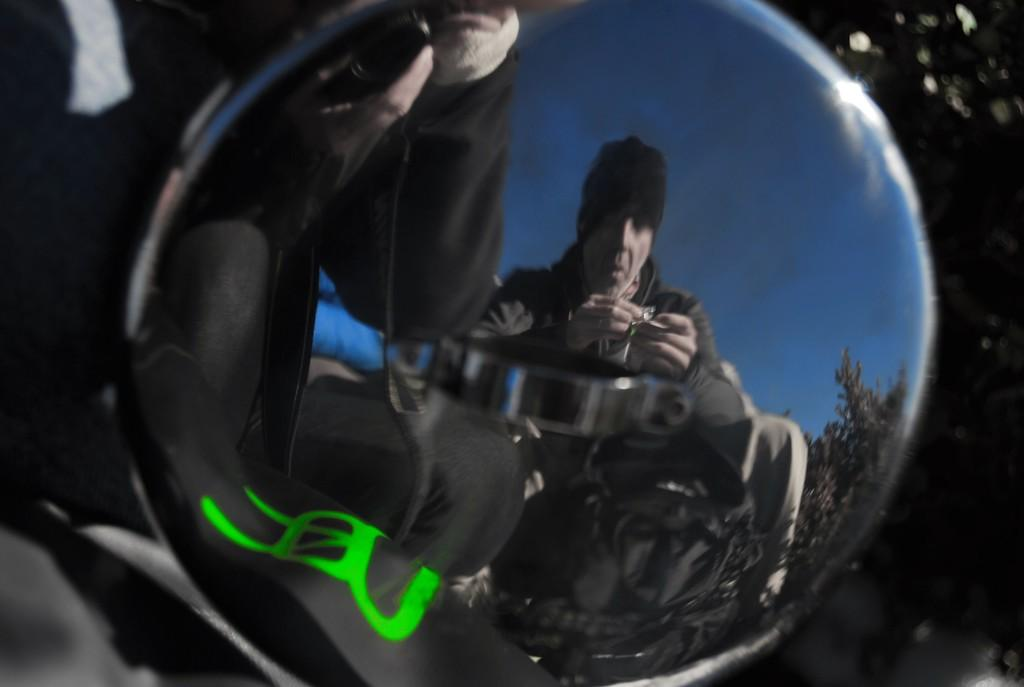How many people are in the image? There are two persons in the image. What can be seen in the background of the image? There is a tree visible in the image, and the sky is also visible. What is the side of the tree that is expanding in the image? There is no indication in the image that the tree is expanding, and the side of the tree cannot be determined from the image. 